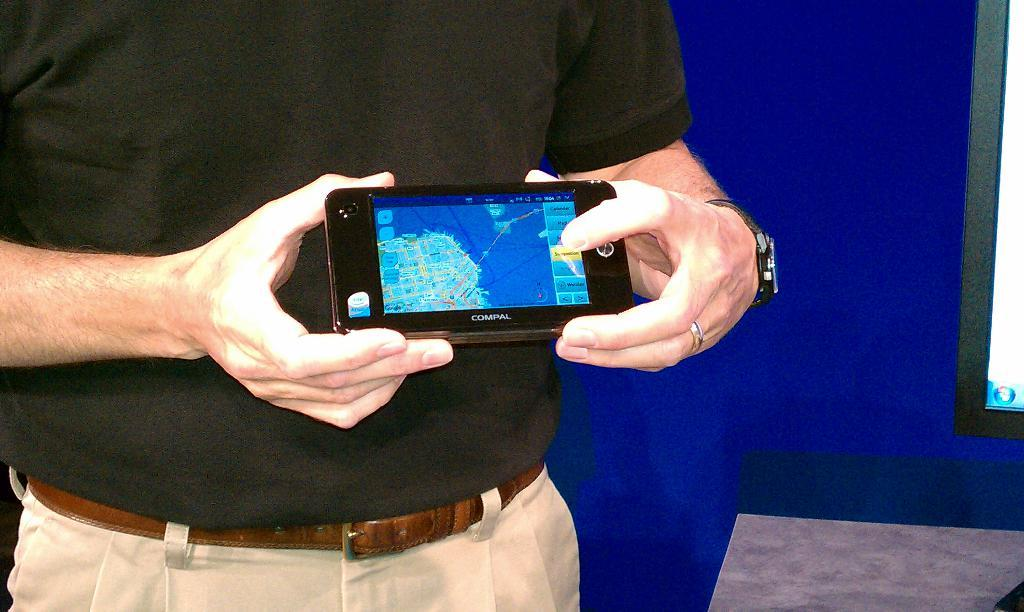What is the main subject in the foreground of the image? There is a person in the foreground of the image. What is the person holding in their hand? The person is holding a mobile in their hand. Where is the person standing in the image? The person is standing on the floor. What can be seen in the background of the image? There is a wall in the background of the image. Can you describe the setting where the image was taken? The image was taken in a hall. What type of machine is being used by the person in the image? There is no machine visible in the image; the person is holding a mobile. Is there a club visible in the image? There is no club present in the image; the setting is a hall. 